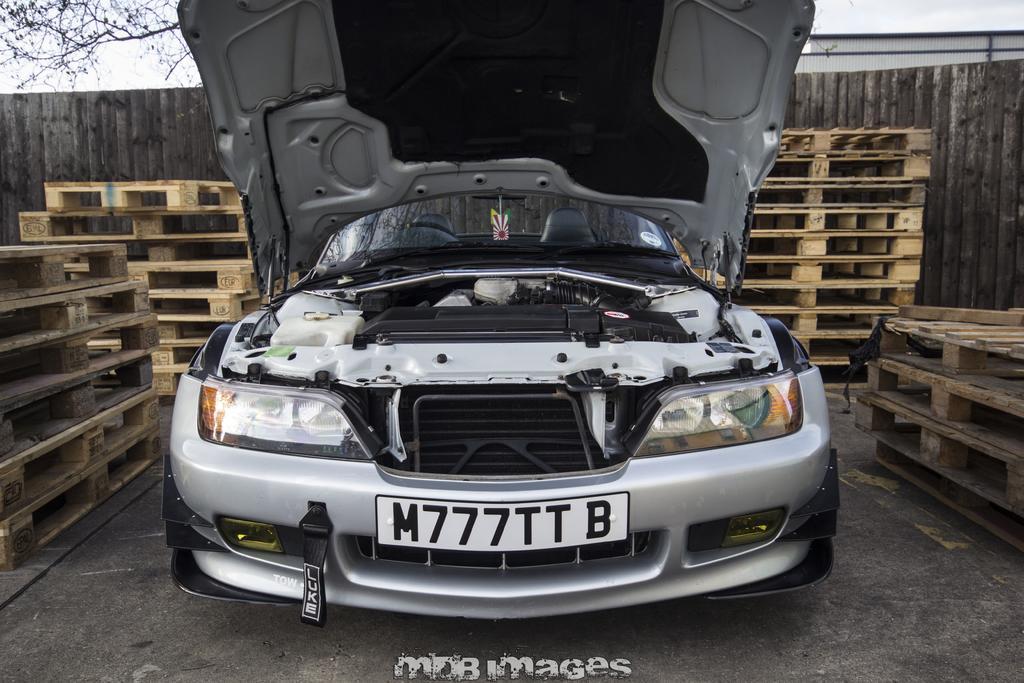Please provide a concise description of this image. In this image I can see a car in the centre and in the front of it I can see something is written on a board. I can also see number of wooden things on the both side and behind the car. In the background I can see branches of a tree, a building and the wall. 